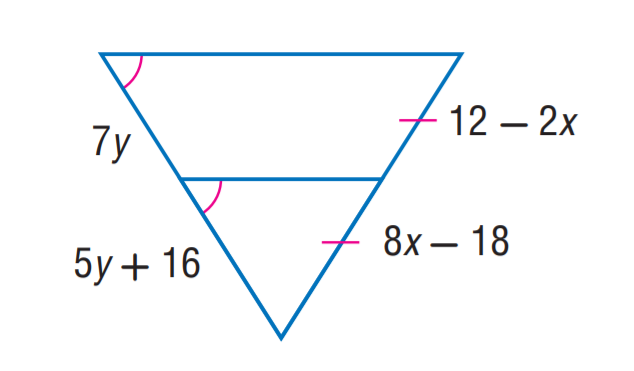Answer the mathemtical geometry problem and directly provide the correct option letter.
Question: Find y.
Choices: A: 7 B: 8 C: 12 D: 16 B 